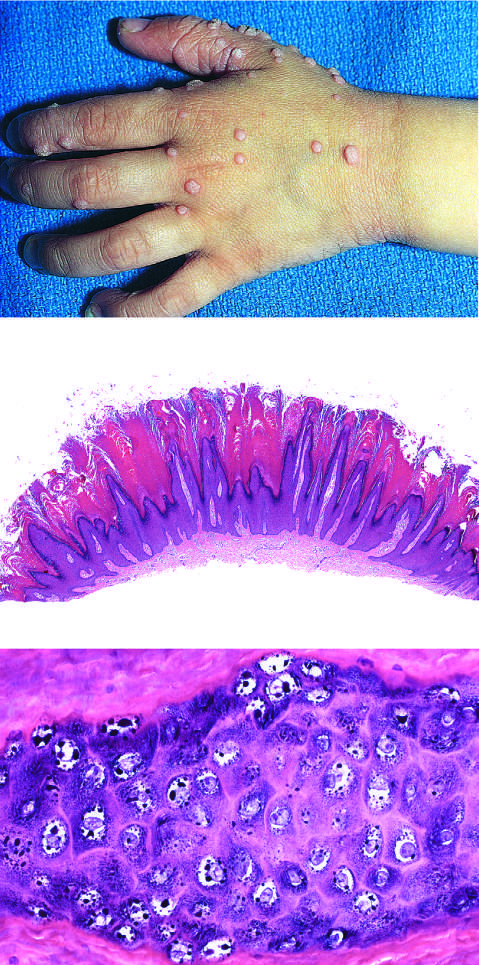re the relative locations, sizes, and distances between genes seen at higher magnification?
Answer the question using a single word or phrase. No 